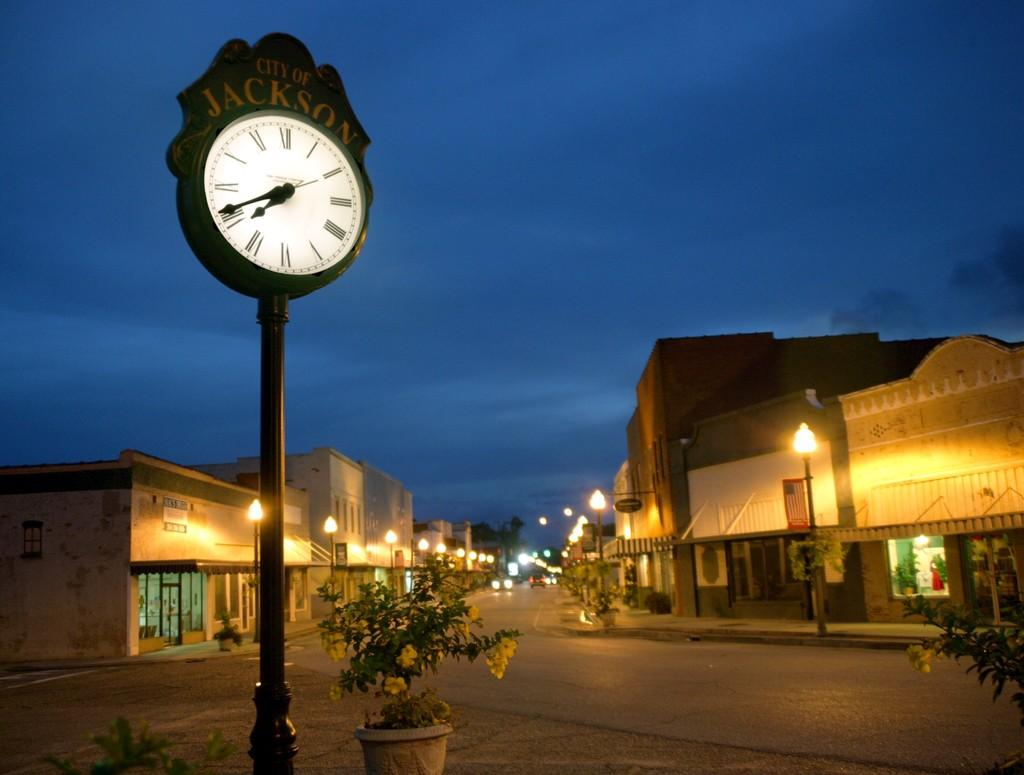Provide a one-sentence caption for the provided image. A clock in the town square of the City of Jackson indicates the time. 